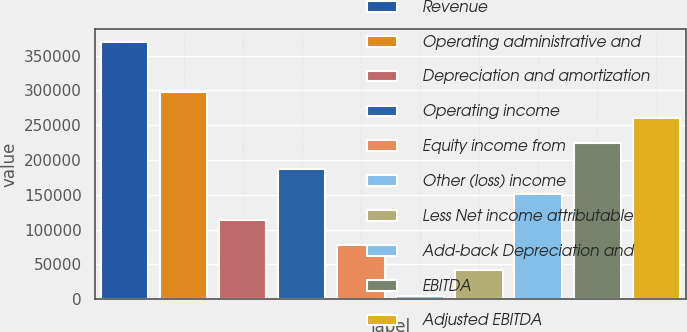<chart> <loc_0><loc_0><loc_500><loc_500><bar_chart><fcel>Revenue<fcel>Operating administrative and<fcel>Depreciation and amortization<fcel>Operating income<fcel>Equity income from<fcel>Other (loss) income<fcel>Less Net income attributable<fcel>Add-back Depreciation and<fcel>EBITDA<fcel>Adjusted EBITDA<nl><fcel>369800<fcel>297194<fcel>114269<fcel>187278<fcel>77764.8<fcel>4756<fcel>41260.4<fcel>150774<fcel>223782<fcel>260287<nl></chart> 